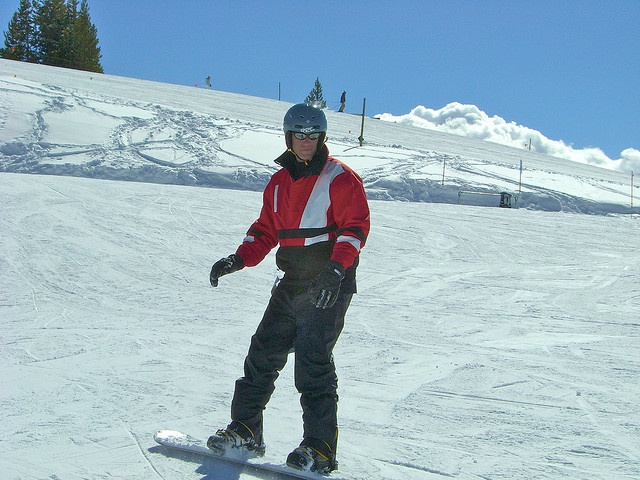Describe the objects in this image and their specific colors. I can see people in gray, black, maroon, and lightblue tones, snowboard in gray and lightgray tones, people in gray, lightblue, blue, and darkblue tones, and people in gray, darkgray, and blue tones in this image. 